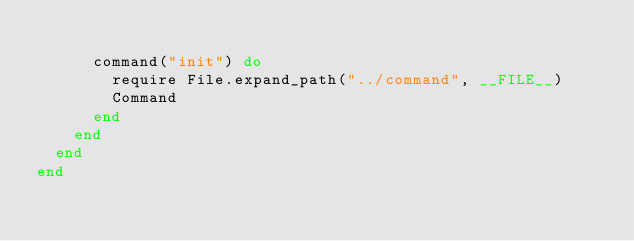<code> <loc_0><loc_0><loc_500><loc_500><_Ruby_>
      command("init") do
        require File.expand_path("../command", __FILE__)
        Command
      end
    end
  end
end
</code> 